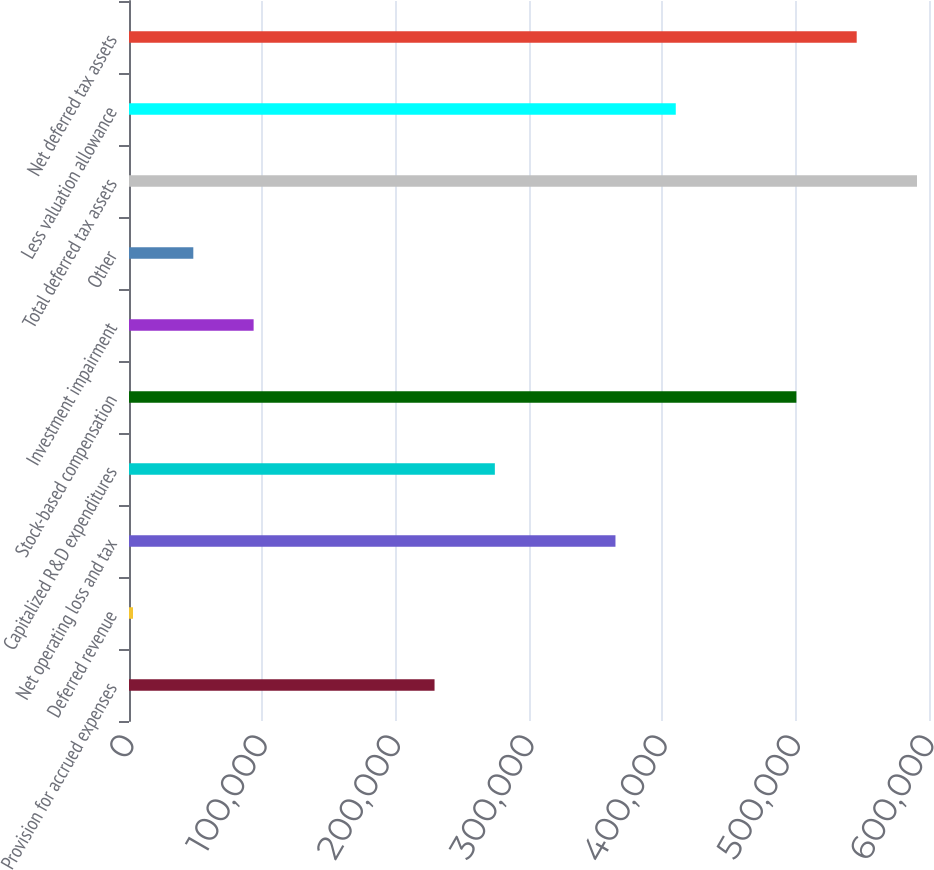Convert chart. <chart><loc_0><loc_0><loc_500><loc_500><bar_chart><fcel>Provision for accrued expenses<fcel>Deferred revenue<fcel>Net operating loss and tax<fcel>Capitalized R&D expenditures<fcel>Stock-based compensation<fcel>Investment impairment<fcel>Other<fcel>Total deferred tax assets<fcel>Less valuation allowance<fcel>Net deferred tax assets<nl><fcel>229158<fcel>3001<fcel>364851<fcel>274389<fcel>500545<fcel>93463.6<fcel>48232.3<fcel>591008<fcel>410083<fcel>545777<nl></chart> 